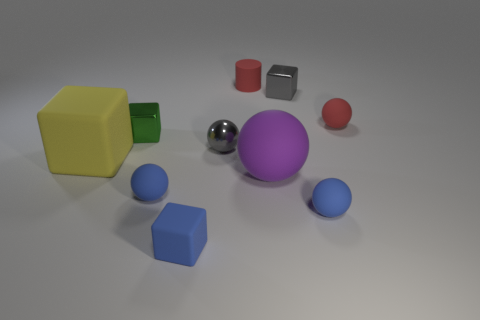How many metal objects are the same color as the tiny metal ball?
Your answer should be very brief. 1. Is the color of the cylinder the same as the small ball behind the tiny green thing?
Make the answer very short. Yes. Are there fewer purple metallic cylinders than big matte balls?
Your answer should be very brief. Yes. Are there more tiny blue objects that are in front of the tiny green metallic thing than cylinders in front of the big purple sphere?
Your response must be concise. Yes. Is the large purple object made of the same material as the big block?
Your answer should be very brief. Yes. How many tiny balls are to the right of the red rubber object that is on the left side of the large purple rubber object?
Provide a short and direct response. 2. Does the metal cube that is to the left of the tiny gray metal sphere have the same color as the rubber cylinder?
Your answer should be very brief. No. How many objects are big metal cubes or rubber objects that are left of the tiny green metal block?
Your response must be concise. 1. Is the shape of the gray thing that is behind the green shiny cube the same as the big thing to the right of the cylinder?
Your response must be concise. No. Are there any other things that are the same color as the large rubber block?
Give a very brief answer. No. 